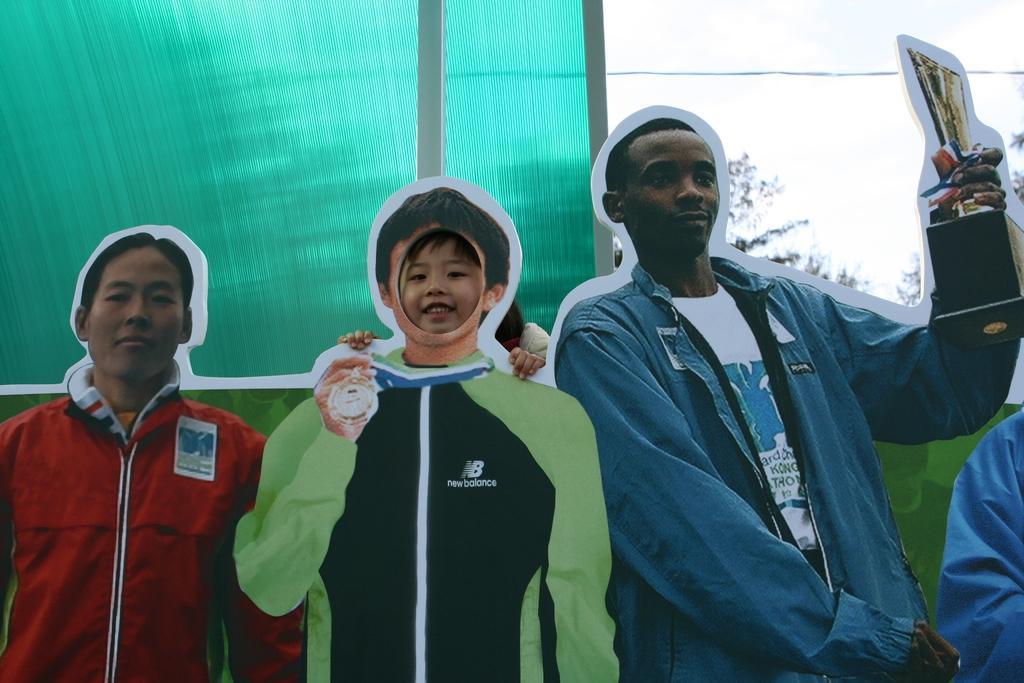Could you give a brief overview of what you see in this image? In the image there are few posters of the people. Behind the posters there is a green background. In the right top corner of the image there is a sky and also there are leaves. 